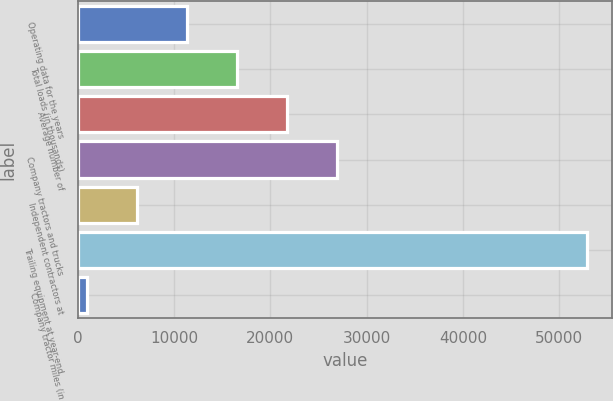Convert chart to OTSL. <chart><loc_0><loc_0><loc_500><loc_500><bar_chart><fcel>Operating data for the years<fcel>Total loads (in thousands)<fcel>Average number of<fcel>Company tractors and trucks<fcel>Independent contractors at<fcel>Trailing equipment at year-end<fcel>Company tractor miles (in<nl><fcel>11348.2<fcel>16539.8<fcel>21731.4<fcel>26923<fcel>6156.6<fcel>52881<fcel>965<nl></chart> 